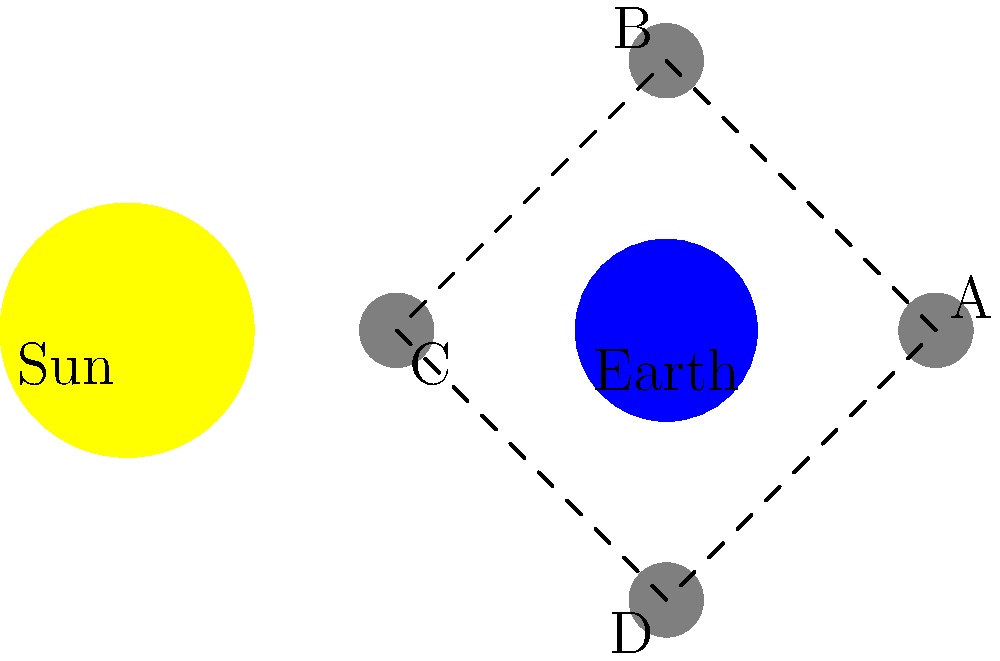In the diagram above, which position of the Moon corresponds to the First Quarter phase as seen from Earth? Consider how this phase might affect a child's sleep patterns or behavior. To answer this question, let's break down the phases of the Moon and their corresponding positions:

1. The First Quarter phase occurs when half of the Moon's illuminated surface is visible from Earth.

2. In this phase, the right half of the Moon appears lit from our perspective on Earth.

3. This happens when the Moon is at a 90-degree angle to the Earth-Sun line, with the Sun illuminating the side of the Moon facing it.

4. Looking at the diagram:
   - Position A: This is the New Moon phase (not visible from Earth)
   - Position B: This is the First Quarter phase
   - Position C: This is the Full Moon phase
   - Position D: This is the Third Quarter phase

5. Therefore, position B corresponds to the First Quarter phase.

As a psychologist parent, it's important to note that some studies suggest lunar phases might affect children's sleep patterns or behavior. The First Quarter moon, being partially illuminated and visible in the early evening, could potentially influence a child's circadian rhythm or anxiety levels. However, scientific evidence for this is mixed, and individual responses may vary.
Answer: B 